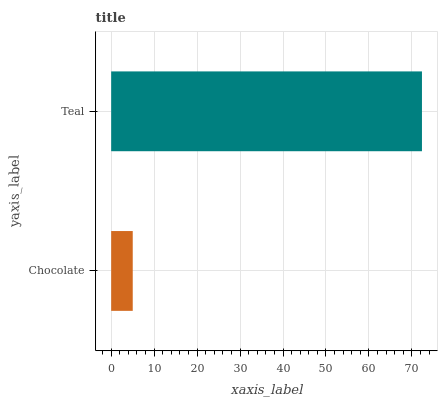Is Chocolate the minimum?
Answer yes or no. Yes. Is Teal the maximum?
Answer yes or no. Yes. Is Teal the minimum?
Answer yes or no. No. Is Teal greater than Chocolate?
Answer yes or no. Yes. Is Chocolate less than Teal?
Answer yes or no. Yes. Is Chocolate greater than Teal?
Answer yes or no. No. Is Teal less than Chocolate?
Answer yes or no. No. Is Teal the high median?
Answer yes or no. Yes. Is Chocolate the low median?
Answer yes or no. Yes. Is Chocolate the high median?
Answer yes or no. No. Is Teal the low median?
Answer yes or no. No. 